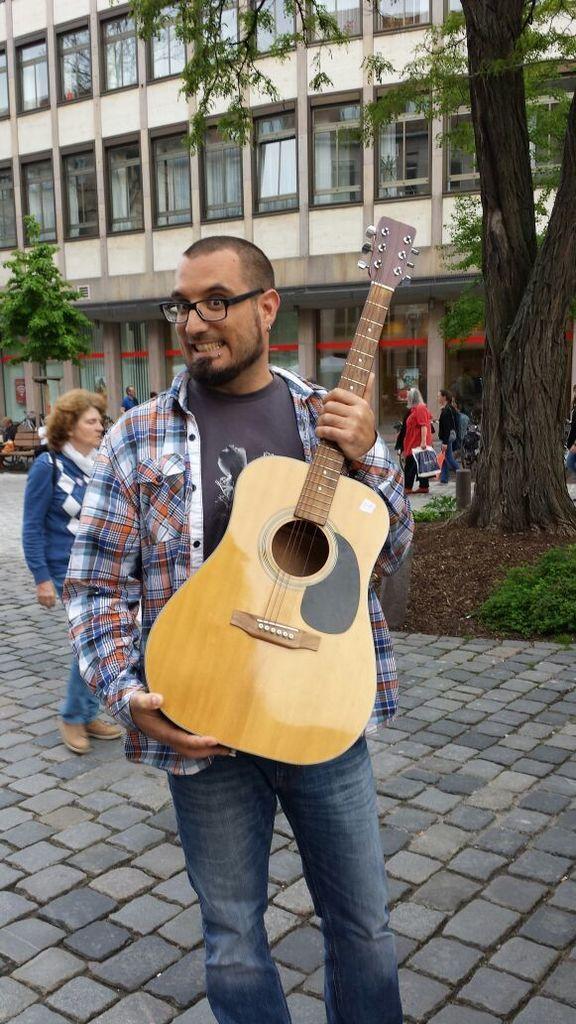Please provide a concise description of this image. In this image there are group of people. In front the man is holding the guitar at the back side there is building and a tree. 